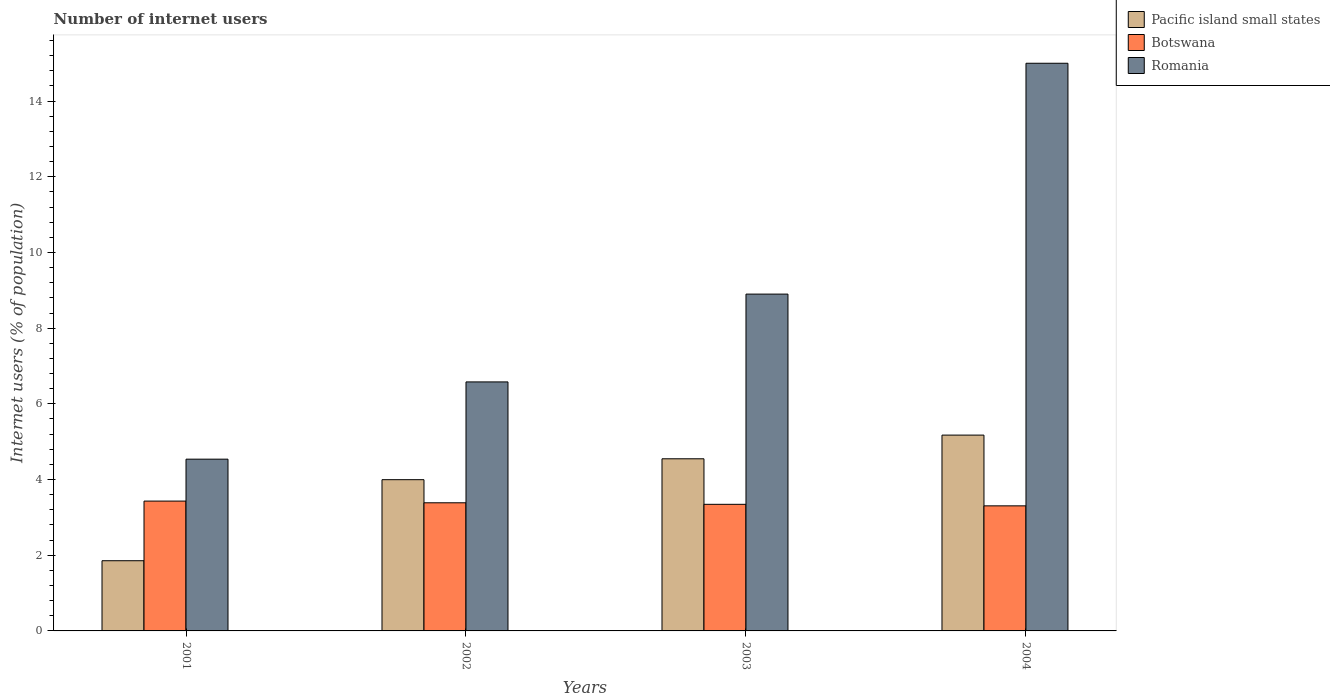How many different coloured bars are there?
Keep it short and to the point. 3. How many groups of bars are there?
Provide a succinct answer. 4. How many bars are there on the 3rd tick from the right?
Offer a terse response. 3. What is the number of internet users in Botswana in 2002?
Make the answer very short. 3.39. Across all years, what is the minimum number of internet users in Botswana?
Make the answer very short. 3.3. In which year was the number of internet users in Botswana maximum?
Keep it short and to the point. 2001. What is the total number of internet users in Romania in the graph?
Offer a very short reply. 35.02. What is the difference between the number of internet users in Pacific island small states in 2002 and that in 2004?
Provide a short and direct response. -1.18. What is the difference between the number of internet users in Romania in 2001 and the number of internet users in Pacific island small states in 2004?
Give a very brief answer. -0.64. What is the average number of internet users in Botswana per year?
Provide a short and direct response. 3.37. In the year 2003, what is the difference between the number of internet users in Botswana and number of internet users in Pacific island small states?
Give a very brief answer. -1.2. What is the ratio of the number of internet users in Botswana in 2003 to that in 2004?
Give a very brief answer. 1.01. Is the difference between the number of internet users in Botswana in 2001 and 2002 greater than the difference between the number of internet users in Pacific island small states in 2001 and 2002?
Give a very brief answer. Yes. What is the difference between the highest and the second highest number of internet users in Pacific island small states?
Your answer should be very brief. 0.63. What is the difference between the highest and the lowest number of internet users in Botswana?
Your answer should be very brief. 0.13. In how many years, is the number of internet users in Botswana greater than the average number of internet users in Botswana taken over all years?
Your answer should be very brief. 2. Is the sum of the number of internet users in Romania in 2001 and 2003 greater than the maximum number of internet users in Botswana across all years?
Make the answer very short. Yes. What does the 1st bar from the left in 2004 represents?
Provide a short and direct response. Pacific island small states. What does the 2nd bar from the right in 2001 represents?
Your answer should be very brief. Botswana. How many bars are there?
Give a very brief answer. 12. Are all the bars in the graph horizontal?
Your answer should be very brief. No. How many years are there in the graph?
Ensure brevity in your answer.  4. What is the difference between two consecutive major ticks on the Y-axis?
Make the answer very short. 2. Are the values on the major ticks of Y-axis written in scientific E-notation?
Your response must be concise. No. Does the graph contain any zero values?
Your response must be concise. No. Does the graph contain grids?
Make the answer very short. No. Where does the legend appear in the graph?
Your response must be concise. Top right. How are the legend labels stacked?
Give a very brief answer. Vertical. What is the title of the graph?
Your answer should be very brief. Number of internet users. Does "Togo" appear as one of the legend labels in the graph?
Provide a succinct answer. No. What is the label or title of the X-axis?
Provide a succinct answer. Years. What is the label or title of the Y-axis?
Ensure brevity in your answer.  Internet users (% of population). What is the Internet users (% of population) of Pacific island small states in 2001?
Your answer should be very brief. 1.86. What is the Internet users (% of population) in Botswana in 2001?
Offer a very short reply. 3.43. What is the Internet users (% of population) of Romania in 2001?
Ensure brevity in your answer.  4.54. What is the Internet users (% of population) in Pacific island small states in 2002?
Keep it short and to the point. 4. What is the Internet users (% of population) of Botswana in 2002?
Make the answer very short. 3.39. What is the Internet users (% of population) in Romania in 2002?
Give a very brief answer. 6.58. What is the Internet users (% of population) of Pacific island small states in 2003?
Offer a terse response. 4.55. What is the Internet users (% of population) of Botswana in 2003?
Offer a terse response. 3.35. What is the Internet users (% of population) in Romania in 2003?
Offer a terse response. 8.9. What is the Internet users (% of population) of Pacific island small states in 2004?
Offer a terse response. 5.17. What is the Internet users (% of population) of Botswana in 2004?
Ensure brevity in your answer.  3.3. What is the Internet users (% of population) of Romania in 2004?
Make the answer very short. 15. Across all years, what is the maximum Internet users (% of population) of Pacific island small states?
Make the answer very short. 5.17. Across all years, what is the maximum Internet users (% of population) in Botswana?
Offer a very short reply. 3.43. Across all years, what is the maximum Internet users (% of population) in Romania?
Offer a terse response. 15. Across all years, what is the minimum Internet users (% of population) in Pacific island small states?
Offer a terse response. 1.86. Across all years, what is the minimum Internet users (% of population) of Botswana?
Provide a short and direct response. 3.3. Across all years, what is the minimum Internet users (% of population) in Romania?
Your response must be concise. 4.54. What is the total Internet users (% of population) in Pacific island small states in the graph?
Give a very brief answer. 15.57. What is the total Internet users (% of population) in Botswana in the graph?
Keep it short and to the point. 13.47. What is the total Internet users (% of population) of Romania in the graph?
Keep it short and to the point. 35.02. What is the difference between the Internet users (% of population) in Pacific island small states in 2001 and that in 2002?
Provide a succinct answer. -2.14. What is the difference between the Internet users (% of population) in Botswana in 2001 and that in 2002?
Ensure brevity in your answer.  0.04. What is the difference between the Internet users (% of population) of Romania in 2001 and that in 2002?
Make the answer very short. -2.04. What is the difference between the Internet users (% of population) of Pacific island small states in 2001 and that in 2003?
Provide a short and direct response. -2.69. What is the difference between the Internet users (% of population) in Botswana in 2001 and that in 2003?
Provide a short and direct response. 0.09. What is the difference between the Internet users (% of population) of Romania in 2001 and that in 2003?
Provide a short and direct response. -4.36. What is the difference between the Internet users (% of population) of Pacific island small states in 2001 and that in 2004?
Give a very brief answer. -3.32. What is the difference between the Internet users (% of population) in Botswana in 2001 and that in 2004?
Keep it short and to the point. 0.13. What is the difference between the Internet users (% of population) of Romania in 2001 and that in 2004?
Your answer should be very brief. -10.46. What is the difference between the Internet users (% of population) in Pacific island small states in 2002 and that in 2003?
Your answer should be compact. -0.55. What is the difference between the Internet users (% of population) of Botswana in 2002 and that in 2003?
Your response must be concise. 0.04. What is the difference between the Internet users (% of population) in Romania in 2002 and that in 2003?
Your answer should be very brief. -2.32. What is the difference between the Internet users (% of population) of Pacific island small states in 2002 and that in 2004?
Ensure brevity in your answer.  -1.18. What is the difference between the Internet users (% of population) of Botswana in 2002 and that in 2004?
Your response must be concise. 0.08. What is the difference between the Internet users (% of population) of Romania in 2002 and that in 2004?
Keep it short and to the point. -8.42. What is the difference between the Internet users (% of population) of Pacific island small states in 2003 and that in 2004?
Make the answer very short. -0.63. What is the difference between the Internet users (% of population) of Botswana in 2003 and that in 2004?
Provide a short and direct response. 0.04. What is the difference between the Internet users (% of population) of Romania in 2003 and that in 2004?
Ensure brevity in your answer.  -6.1. What is the difference between the Internet users (% of population) of Pacific island small states in 2001 and the Internet users (% of population) of Botswana in 2002?
Make the answer very short. -1.53. What is the difference between the Internet users (% of population) of Pacific island small states in 2001 and the Internet users (% of population) of Romania in 2002?
Your response must be concise. -4.72. What is the difference between the Internet users (% of population) in Botswana in 2001 and the Internet users (% of population) in Romania in 2002?
Ensure brevity in your answer.  -3.15. What is the difference between the Internet users (% of population) of Pacific island small states in 2001 and the Internet users (% of population) of Botswana in 2003?
Ensure brevity in your answer.  -1.49. What is the difference between the Internet users (% of population) in Pacific island small states in 2001 and the Internet users (% of population) in Romania in 2003?
Keep it short and to the point. -7.04. What is the difference between the Internet users (% of population) in Botswana in 2001 and the Internet users (% of population) in Romania in 2003?
Offer a terse response. -5.47. What is the difference between the Internet users (% of population) of Pacific island small states in 2001 and the Internet users (% of population) of Botswana in 2004?
Provide a short and direct response. -1.45. What is the difference between the Internet users (% of population) in Pacific island small states in 2001 and the Internet users (% of population) in Romania in 2004?
Provide a succinct answer. -13.14. What is the difference between the Internet users (% of population) of Botswana in 2001 and the Internet users (% of population) of Romania in 2004?
Keep it short and to the point. -11.57. What is the difference between the Internet users (% of population) of Pacific island small states in 2002 and the Internet users (% of population) of Botswana in 2003?
Offer a terse response. 0.65. What is the difference between the Internet users (% of population) of Pacific island small states in 2002 and the Internet users (% of population) of Romania in 2003?
Offer a terse response. -4.9. What is the difference between the Internet users (% of population) of Botswana in 2002 and the Internet users (% of population) of Romania in 2003?
Offer a terse response. -5.51. What is the difference between the Internet users (% of population) of Pacific island small states in 2002 and the Internet users (% of population) of Botswana in 2004?
Your response must be concise. 0.69. What is the difference between the Internet users (% of population) of Pacific island small states in 2002 and the Internet users (% of population) of Romania in 2004?
Your response must be concise. -11. What is the difference between the Internet users (% of population) in Botswana in 2002 and the Internet users (% of population) in Romania in 2004?
Ensure brevity in your answer.  -11.61. What is the difference between the Internet users (% of population) in Pacific island small states in 2003 and the Internet users (% of population) in Botswana in 2004?
Keep it short and to the point. 1.24. What is the difference between the Internet users (% of population) of Pacific island small states in 2003 and the Internet users (% of population) of Romania in 2004?
Provide a short and direct response. -10.45. What is the difference between the Internet users (% of population) in Botswana in 2003 and the Internet users (% of population) in Romania in 2004?
Provide a succinct answer. -11.65. What is the average Internet users (% of population) of Pacific island small states per year?
Offer a terse response. 3.89. What is the average Internet users (% of population) in Botswana per year?
Offer a terse response. 3.37. What is the average Internet users (% of population) in Romania per year?
Your answer should be compact. 8.75. In the year 2001, what is the difference between the Internet users (% of population) in Pacific island small states and Internet users (% of population) in Botswana?
Your answer should be compact. -1.58. In the year 2001, what is the difference between the Internet users (% of population) of Pacific island small states and Internet users (% of population) of Romania?
Provide a short and direct response. -2.68. In the year 2001, what is the difference between the Internet users (% of population) in Botswana and Internet users (% of population) in Romania?
Provide a succinct answer. -1.11. In the year 2002, what is the difference between the Internet users (% of population) in Pacific island small states and Internet users (% of population) in Botswana?
Provide a short and direct response. 0.61. In the year 2002, what is the difference between the Internet users (% of population) of Pacific island small states and Internet users (% of population) of Romania?
Give a very brief answer. -2.58. In the year 2002, what is the difference between the Internet users (% of population) of Botswana and Internet users (% of population) of Romania?
Make the answer very short. -3.19. In the year 2003, what is the difference between the Internet users (% of population) in Pacific island small states and Internet users (% of population) in Botswana?
Keep it short and to the point. 1.2. In the year 2003, what is the difference between the Internet users (% of population) in Pacific island small states and Internet users (% of population) in Romania?
Offer a very short reply. -4.35. In the year 2003, what is the difference between the Internet users (% of population) in Botswana and Internet users (% of population) in Romania?
Offer a very short reply. -5.55. In the year 2004, what is the difference between the Internet users (% of population) in Pacific island small states and Internet users (% of population) in Botswana?
Make the answer very short. 1.87. In the year 2004, what is the difference between the Internet users (% of population) of Pacific island small states and Internet users (% of population) of Romania?
Make the answer very short. -9.83. In the year 2004, what is the difference between the Internet users (% of population) in Botswana and Internet users (% of population) in Romania?
Offer a terse response. -11.7. What is the ratio of the Internet users (% of population) in Pacific island small states in 2001 to that in 2002?
Make the answer very short. 0.46. What is the ratio of the Internet users (% of population) of Botswana in 2001 to that in 2002?
Your answer should be compact. 1.01. What is the ratio of the Internet users (% of population) in Romania in 2001 to that in 2002?
Your answer should be compact. 0.69. What is the ratio of the Internet users (% of population) in Pacific island small states in 2001 to that in 2003?
Make the answer very short. 0.41. What is the ratio of the Internet users (% of population) in Botswana in 2001 to that in 2003?
Your answer should be very brief. 1.03. What is the ratio of the Internet users (% of population) of Romania in 2001 to that in 2003?
Provide a succinct answer. 0.51. What is the ratio of the Internet users (% of population) of Pacific island small states in 2001 to that in 2004?
Offer a terse response. 0.36. What is the ratio of the Internet users (% of population) in Botswana in 2001 to that in 2004?
Your response must be concise. 1.04. What is the ratio of the Internet users (% of population) of Romania in 2001 to that in 2004?
Your response must be concise. 0.3. What is the ratio of the Internet users (% of population) of Pacific island small states in 2002 to that in 2003?
Keep it short and to the point. 0.88. What is the ratio of the Internet users (% of population) in Botswana in 2002 to that in 2003?
Provide a succinct answer. 1.01. What is the ratio of the Internet users (% of population) in Romania in 2002 to that in 2003?
Provide a succinct answer. 0.74. What is the ratio of the Internet users (% of population) in Pacific island small states in 2002 to that in 2004?
Your answer should be very brief. 0.77. What is the ratio of the Internet users (% of population) in Botswana in 2002 to that in 2004?
Offer a very short reply. 1.02. What is the ratio of the Internet users (% of population) in Romania in 2002 to that in 2004?
Your answer should be very brief. 0.44. What is the ratio of the Internet users (% of population) in Pacific island small states in 2003 to that in 2004?
Your response must be concise. 0.88. What is the ratio of the Internet users (% of population) of Botswana in 2003 to that in 2004?
Offer a very short reply. 1.01. What is the ratio of the Internet users (% of population) in Romania in 2003 to that in 2004?
Give a very brief answer. 0.59. What is the difference between the highest and the second highest Internet users (% of population) in Pacific island small states?
Offer a terse response. 0.63. What is the difference between the highest and the second highest Internet users (% of population) of Botswana?
Ensure brevity in your answer.  0.04. What is the difference between the highest and the second highest Internet users (% of population) in Romania?
Provide a short and direct response. 6.1. What is the difference between the highest and the lowest Internet users (% of population) of Pacific island small states?
Provide a short and direct response. 3.32. What is the difference between the highest and the lowest Internet users (% of population) of Botswana?
Ensure brevity in your answer.  0.13. What is the difference between the highest and the lowest Internet users (% of population) of Romania?
Provide a succinct answer. 10.46. 